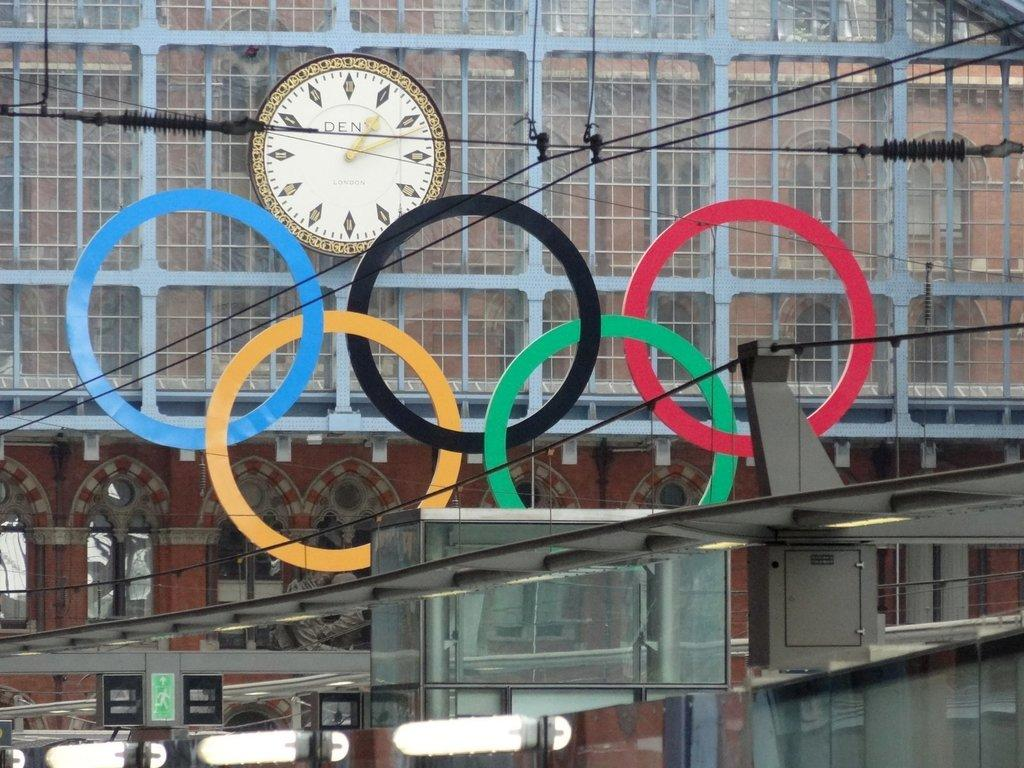Provide a one-sentence caption for the provided image. Olympic rings decorate a building with a clock that says DEN on it. 